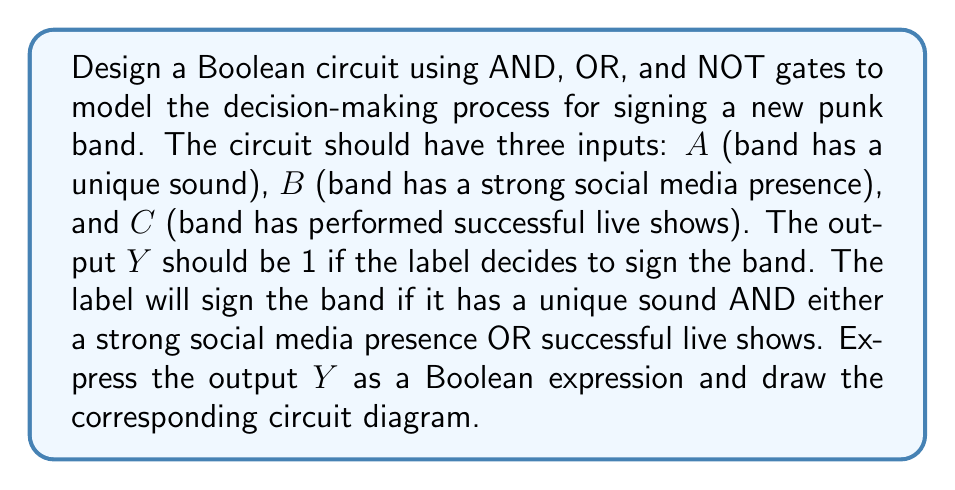Can you answer this question? 1. Analyze the decision-making criteria:
   - The band must have a unique sound (A)
   - The band must also have either a strong social media presence (B) OR successful live shows (C)

2. Translate the criteria into a Boolean expression:
   $Y = A \cdot (B + C)$

3. Break down the expression into basic logic gates:
   - $(B + C)$ represents an OR operation between B and C
   - $A \cdot (B + C)$ represents an AND operation between A and the result of (B + C)

4. Design the circuit:
   - Use an OR gate for (B + C)
   - Use an AND gate to combine A with the result of (B + C)

5. Draw the circuit diagram:
[asy]
import geometry;

// Define points
pair A = (0,80), B = (0,40), C = (0,0);
pair OR = (80,20), AND = (160,50), Y = (240,50);

// Draw input lines
draw(A--OR+(0,20));
draw(B--OR+(0,0));
draw(C--OR-(0,20));

// Draw OR gate
draw(OR+(0,-30)--OR+(0,30)--OR+(30,0)--cycle);
label("OR", OR+(15,0), E);

// Draw AND gate
draw(AND+(0,-30)--AND+(0,30)--AND+(30,0)--cycle);
label("AND", AND+(15,0), E);

// Connect OR to AND
draw(OR+(30,0)--AND+(0,-20));

// Connect A to AND
draw(A--(AND+(0,20)));

// Connect AND to output
draw(AND+(30,0)--Y);

// Label inputs and output
label("A", A, W);
label("B", B, W);
label("C", C, W);
label("Y", Y, E);
[/asy]

6. The resulting Boolean expression for the output Y is:
   $Y = A \cdot (B + C)$

This circuit accurately models the decision-making process for signing a new punk band based on the given criteria.
Answer: $Y = A \cdot (B + C)$ 